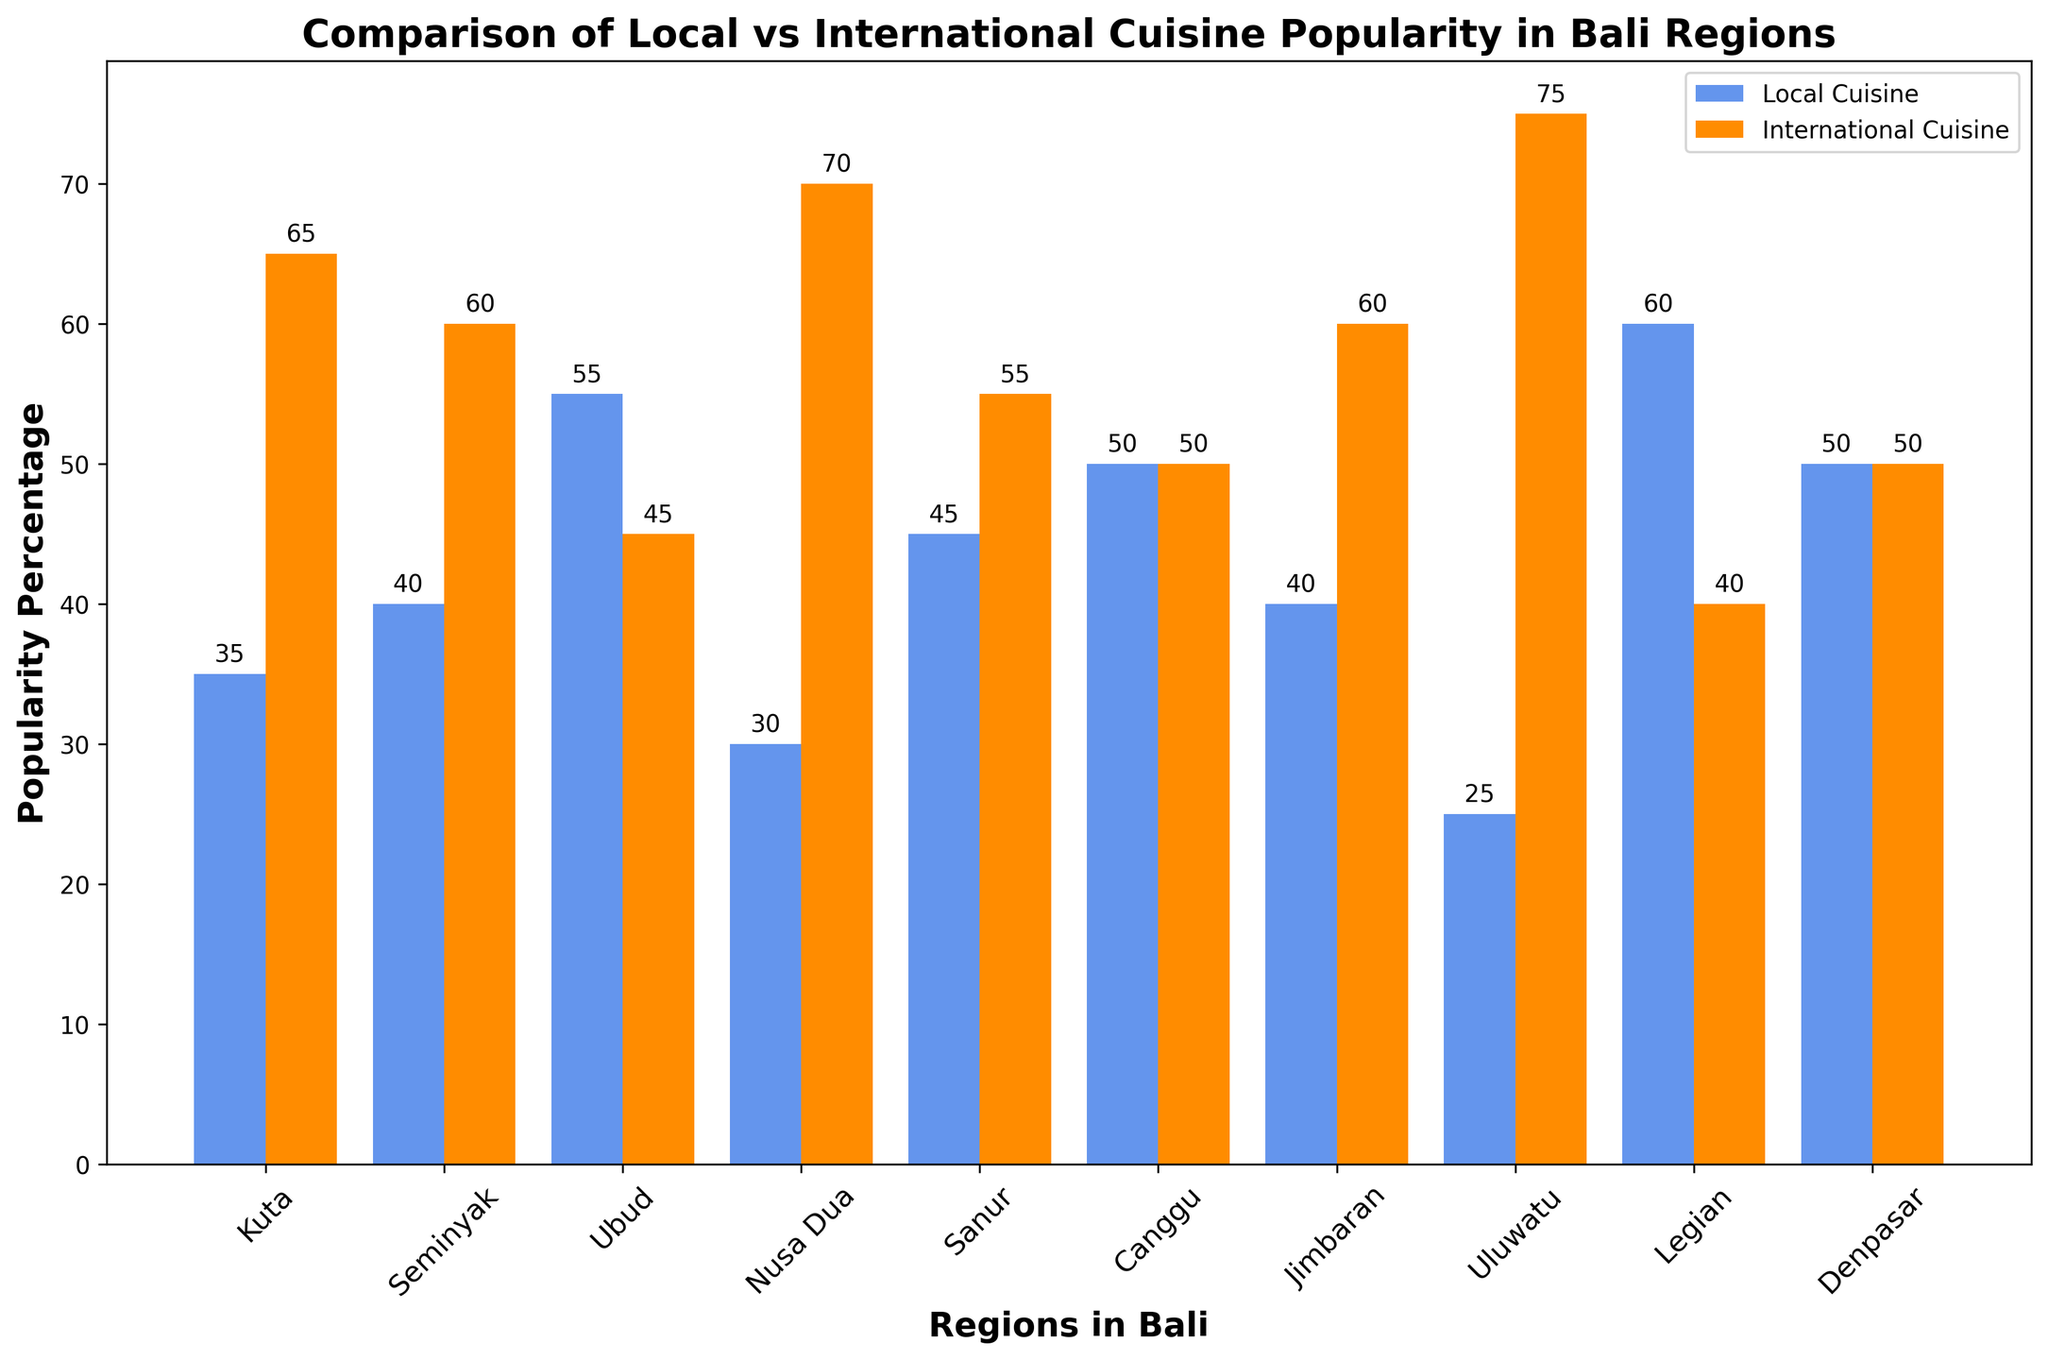What's the region with the highest popularity for local cuisine? To identify the region with the highest popularity of local cuisine, we look for the tallest bar in the "Local Cuisine" category. The tallest bar appears to be in Legian, indicating it has the highest local cuisine popularity.
Answer: Legian Which region prefers international cuisine the most? To find the region with the highest preference for international cuisine, we examine the tallest bar under the "International Cuisine" category. The tallest bar is in Uluwatu, indicating the highest preference for international cuisine.
Answer: Uluwatu What is the difference in local cuisine popularity between Ubud and Canggu? First, identify the local cuisine popularity in Ubud (55) and Canggu (50). Then, find the difference between the two values: 55 - 50 = 5.
Answer: 5 In which regions is the popularity of local and international cuisines equal? We look for regions where the bars for local and international cuisines have the same height. The equal heights appear in Canggu and Denpasar, which means the popularity is equal in these regions.
Answer: Canggu, Denpasar Rank the regions from highest to lowest popularity for international cuisine. To rank the regions, we list them in descending order based on the heights of the international cuisine bars: Uluwatu (75), Nusa Dua (70), Kuta (65), Jimbaran (60), Seminyak (60), Sanur (55), Ubud (45), Legian (40), Canggu (50), Denpasar (50).
Answer: Uluwatu, Nusa Dua, Kuta, Jimbaran, Seminyak, Sanur, Canggu/Denpasar, Ubud, Legian What is the average popularity of local cuisine across all regions? Sum the local cuisine popularity values: 35 + 40 + 55 + 30 + 45 + 50 + 40 + 25 + 60 + 50 = 430. Then, divide by the number of regions (10): 430 / 10 = 43.
Answer: 43 Compare the total popularity of local cuisine in Kuta and Seminyak with Nusa Dua and Uluwatu. Which pair has a higher combined popularity? First, sum the local cuisine popularities: Kuta (35) and Seminyak (40) = 35 + 40 = 75. Nusa Dua (30) and Uluwatu (25) = 30 + 25 = 55. The combined popularity of Kuta and Seminyak is higher.
Answer: Kuta and Seminyak Which region shows the least interest in local cuisine? Identify the shortest bar in the local cuisine category. The shortest bar is in Uluwatu (25), indicating the least interest in local cuisine.
Answer: Uluwatu What is the combined popularity of international cuisine for Ubud and Jimbaran? Sum the international cuisine popularity values for Ubud (45) and Jimbaran (60): 45 + 60 = 105.
Answer: 105 